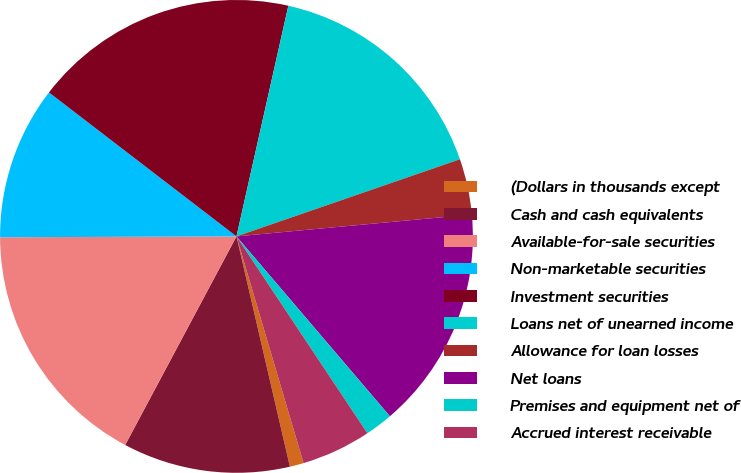<chart> <loc_0><loc_0><loc_500><loc_500><pie_chart><fcel>(Dollars in thousands except<fcel>Cash and cash equivalents<fcel>Available-for-sale securities<fcel>Non-marketable securities<fcel>Investment securities<fcel>Loans net of unearned income<fcel>Allowance for loan losses<fcel>Net loans<fcel>Premises and equipment net of<fcel>Accrued interest receivable<nl><fcel>0.95%<fcel>11.43%<fcel>17.14%<fcel>10.48%<fcel>18.1%<fcel>16.19%<fcel>3.81%<fcel>15.24%<fcel>1.9%<fcel>4.76%<nl></chart> 